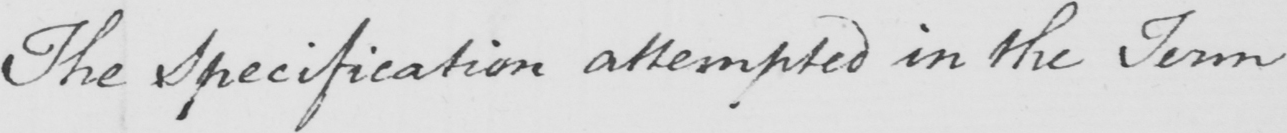What does this handwritten line say? The Specification attempted in the Term 